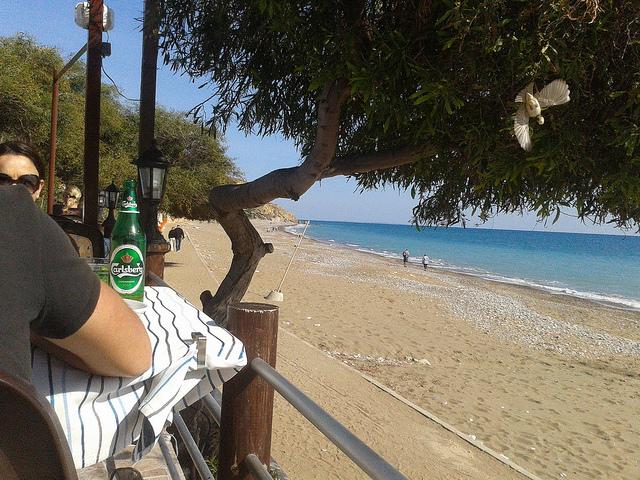What is inside the green bottle on the table?

Choices:
A) juice
B) beer
C) champagne
D) wine beer 